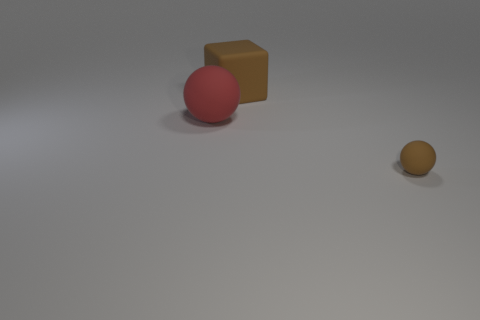Is there anything else that has the same size as the brown ball?
Your answer should be very brief. No. The other rubber thing that is the same color as the tiny rubber object is what size?
Provide a succinct answer. Large. There is a matte sphere that is on the left side of the brown object that is behind the red rubber sphere on the left side of the tiny brown thing; what is its color?
Your answer should be compact. Red. What number of cyan things are matte blocks or big rubber balls?
Your answer should be compact. 0. What number of red objects are on the left side of the tiny ball?
Offer a terse response. 1. Is the number of large yellow metallic blocks greater than the number of brown matte spheres?
Give a very brief answer. No. The brown object left of the tiny matte sphere in front of the block is what shape?
Make the answer very short. Cube. Does the small object have the same color as the rubber cube?
Your answer should be compact. Yes. Are there more large brown cubes that are to the left of the small brown thing than gray metallic balls?
Ensure brevity in your answer.  Yes. How many big brown blocks are on the right side of the rubber object right of the brown matte block?
Make the answer very short. 0. 